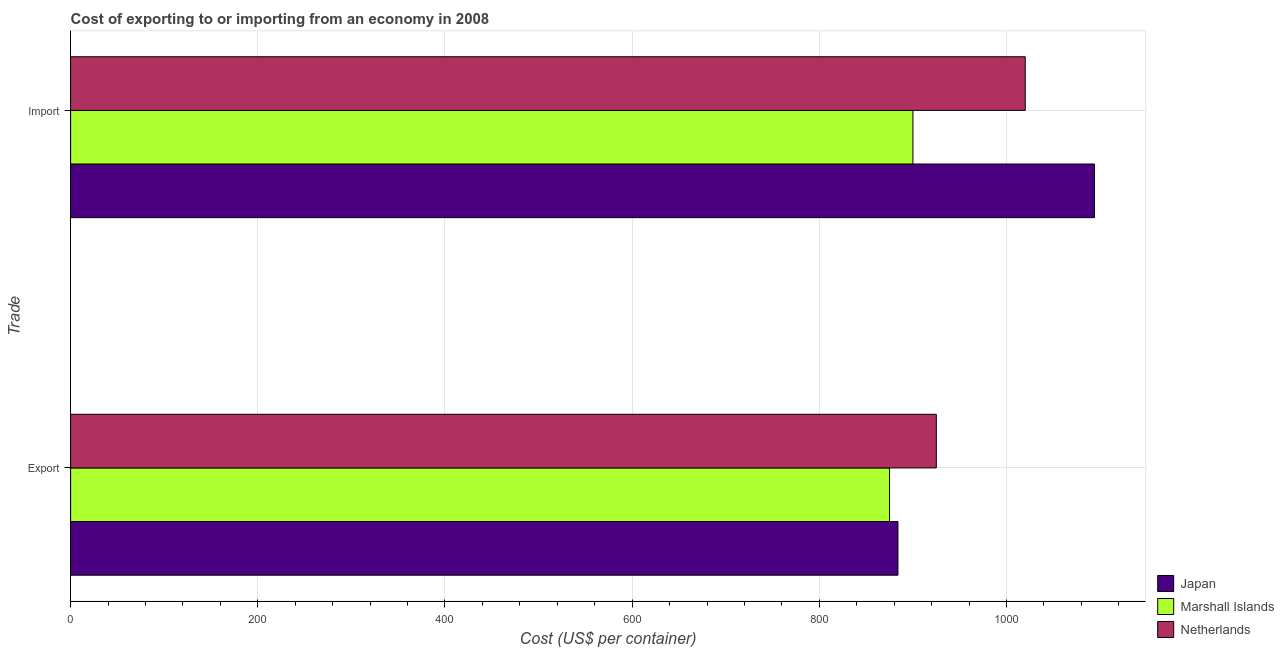Are the number of bars per tick equal to the number of legend labels?
Your answer should be very brief. Yes. How many bars are there on the 1st tick from the bottom?
Your answer should be compact. 3. What is the label of the 2nd group of bars from the top?
Make the answer very short. Export. What is the import cost in Marshall Islands?
Your response must be concise. 900. Across all countries, what is the maximum import cost?
Offer a very short reply. 1094. Across all countries, what is the minimum export cost?
Your answer should be compact. 875. In which country was the import cost maximum?
Provide a short and direct response. Japan. In which country was the import cost minimum?
Your answer should be very brief. Marshall Islands. What is the total export cost in the graph?
Give a very brief answer. 2684. What is the difference between the export cost in Marshall Islands and that in Netherlands?
Make the answer very short. -50. What is the difference between the export cost in Marshall Islands and the import cost in Netherlands?
Your answer should be compact. -145. What is the average export cost per country?
Offer a terse response. 894.67. What is the difference between the export cost and import cost in Japan?
Your answer should be very brief. -210. In how many countries, is the import cost greater than 480 US$?
Offer a very short reply. 3. What is the ratio of the export cost in Japan to that in Marshall Islands?
Offer a terse response. 1.01. In how many countries, is the export cost greater than the average export cost taken over all countries?
Your response must be concise. 1. What does the 1st bar from the top in Export represents?
Offer a very short reply. Netherlands. What does the 2nd bar from the bottom in Import represents?
Your response must be concise. Marshall Islands. How many bars are there?
Offer a very short reply. 6. Are all the bars in the graph horizontal?
Give a very brief answer. Yes. How many countries are there in the graph?
Ensure brevity in your answer.  3. What is the difference between two consecutive major ticks on the X-axis?
Give a very brief answer. 200. Does the graph contain grids?
Keep it short and to the point. Yes. What is the title of the graph?
Ensure brevity in your answer.  Cost of exporting to or importing from an economy in 2008. What is the label or title of the X-axis?
Provide a short and direct response. Cost (US$ per container). What is the label or title of the Y-axis?
Provide a short and direct response. Trade. What is the Cost (US$ per container) of Japan in Export?
Your answer should be compact. 884. What is the Cost (US$ per container) in Marshall Islands in Export?
Keep it short and to the point. 875. What is the Cost (US$ per container) of Netherlands in Export?
Your answer should be compact. 925. What is the Cost (US$ per container) of Japan in Import?
Offer a very short reply. 1094. What is the Cost (US$ per container) of Marshall Islands in Import?
Make the answer very short. 900. What is the Cost (US$ per container) of Netherlands in Import?
Your response must be concise. 1020. Across all Trade, what is the maximum Cost (US$ per container) in Japan?
Ensure brevity in your answer.  1094. Across all Trade, what is the maximum Cost (US$ per container) of Marshall Islands?
Make the answer very short. 900. Across all Trade, what is the maximum Cost (US$ per container) of Netherlands?
Your answer should be compact. 1020. Across all Trade, what is the minimum Cost (US$ per container) of Japan?
Ensure brevity in your answer.  884. Across all Trade, what is the minimum Cost (US$ per container) in Marshall Islands?
Keep it short and to the point. 875. Across all Trade, what is the minimum Cost (US$ per container) in Netherlands?
Your answer should be compact. 925. What is the total Cost (US$ per container) in Japan in the graph?
Your response must be concise. 1978. What is the total Cost (US$ per container) in Marshall Islands in the graph?
Keep it short and to the point. 1775. What is the total Cost (US$ per container) of Netherlands in the graph?
Your answer should be very brief. 1945. What is the difference between the Cost (US$ per container) in Japan in Export and that in Import?
Give a very brief answer. -210. What is the difference between the Cost (US$ per container) of Marshall Islands in Export and that in Import?
Keep it short and to the point. -25. What is the difference between the Cost (US$ per container) of Netherlands in Export and that in Import?
Your response must be concise. -95. What is the difference between the Cost (US$ per container) in Japan in Export and the Cost (US$ per container) in Marshall Islands in Import?
Provide a short and direct response. -16. What is the difference between the Cost (US$ per container) in Japan in Export and the Cost (US$ per container) in Netherlands in Import?
Provide a short and direct response. -136. What is the difference between the Cost (US$ per container) in Marshall Islands in Export and the Cost (US$ per container) in Netherlands in Import?
Your answer should be very brief. -145. What is the average Cost (US$ per container) of Japan per Trade?
Give a very brief answer. 989. What is the average Cost (US$ per container) of Marshall Islands per Trade?
Keep it short and to the point. 887.5. What is the average Cost (US$ per container) in Netherlands per Trade?
Make the answer very short. 972.5. What is the difference between the Cost (US$ per container) in Japan and Cost (US$ per container) in Marshall Islands in Export?
Make the answer very short. 9. What is the difference between the Cost (US$ per container) in Japan and Cost (US$ per container) in Netherlands in Export?
Ensure brevity in your answer.  -41. What is the difference between the Cost (US$ per container) in Japan and Cost (US$ per container) in Marshall Islands in Import?
Give a very brief answer. 194. What is the difference between the Cost (US$ per container) of Marshall Islands and Cost (US$ per container) of Netherlands in Import?
Keep it short and to the point. -120. What is the ratio of the Cost (US$ per container) of Japan in Export to that in Import?
Give a very brief answer. 0.81. What is the ratio of the Cost (US$ per container) in Marshall Islands in Export to that in Import?
Offer a terse response. 0.97. What is the ratio of the Cost (US$ per container) of Netherlands in Export to that in Import?
Offer a terse response. 0.91. What is the difference between the highest and the second highest Cost (US$ per container) in Japan?
Make the answer very short. 210. What is the difference between the highest and the lowest Cost (US$ per container) in Japan?
Offer a terse response. 210. What is the difference between the highest and the lowest Cost (US$ per container) of Netherlands?
Your response must be concise. 95. 